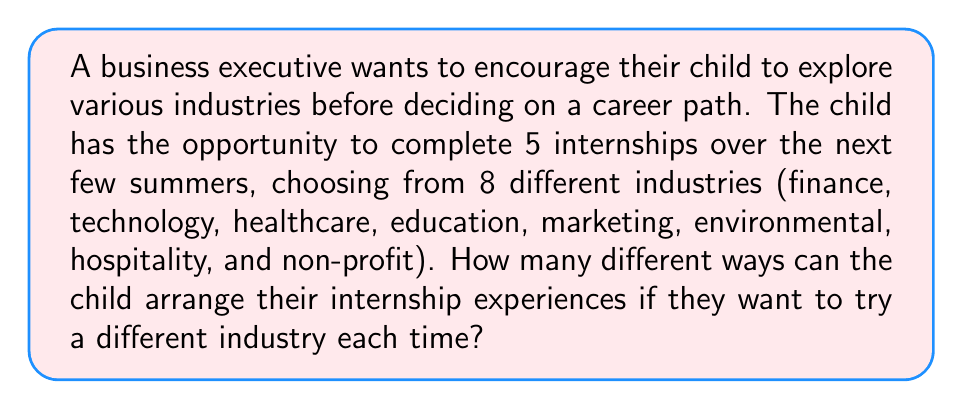Could you help me with this problem? To solve this problem, we need to use the concept of permutations. Here's a step-by-step explanation:

1) We are selecting 5 industries out of 8, where the order matters (as we're arranging the internships), and we can't repeat an industry.

2) This scenario is a perfect fit for the permutation formula:
   
   $$P(n,r) = \frac{n!}{(n-r)!}$$

   Where $n$ is the total number of options (8 industries) and $r$ is the number of selections (5 internships).

3) Plugging in our values:
   
   $$P(8,5) = \frac{8!}{(8-5)!} = \frac{8!}{3!}$$

4) Let's calculate this:
   
   $$\frac{8!}{3!} = \frac{8 \times 7 \times 6 \times 5 \times 4 \times 3!}{3!}$$

5) The $3!$ cancels out in the numerator and denominator:
   
   $$8 \times 7 \times 6 \times 5 \times 4 = 6720$$

Therefore, there are 6720 different ways for the child to arrange their 5 internships across the 8 different industries.
Answer: 6720 